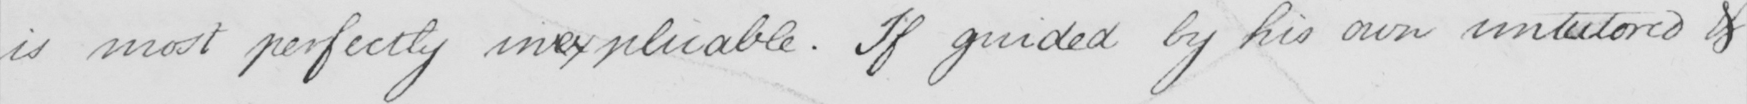Can you tell me what this handwritten text says? is most perfectly inexplicable . If guided by his own untutored & 